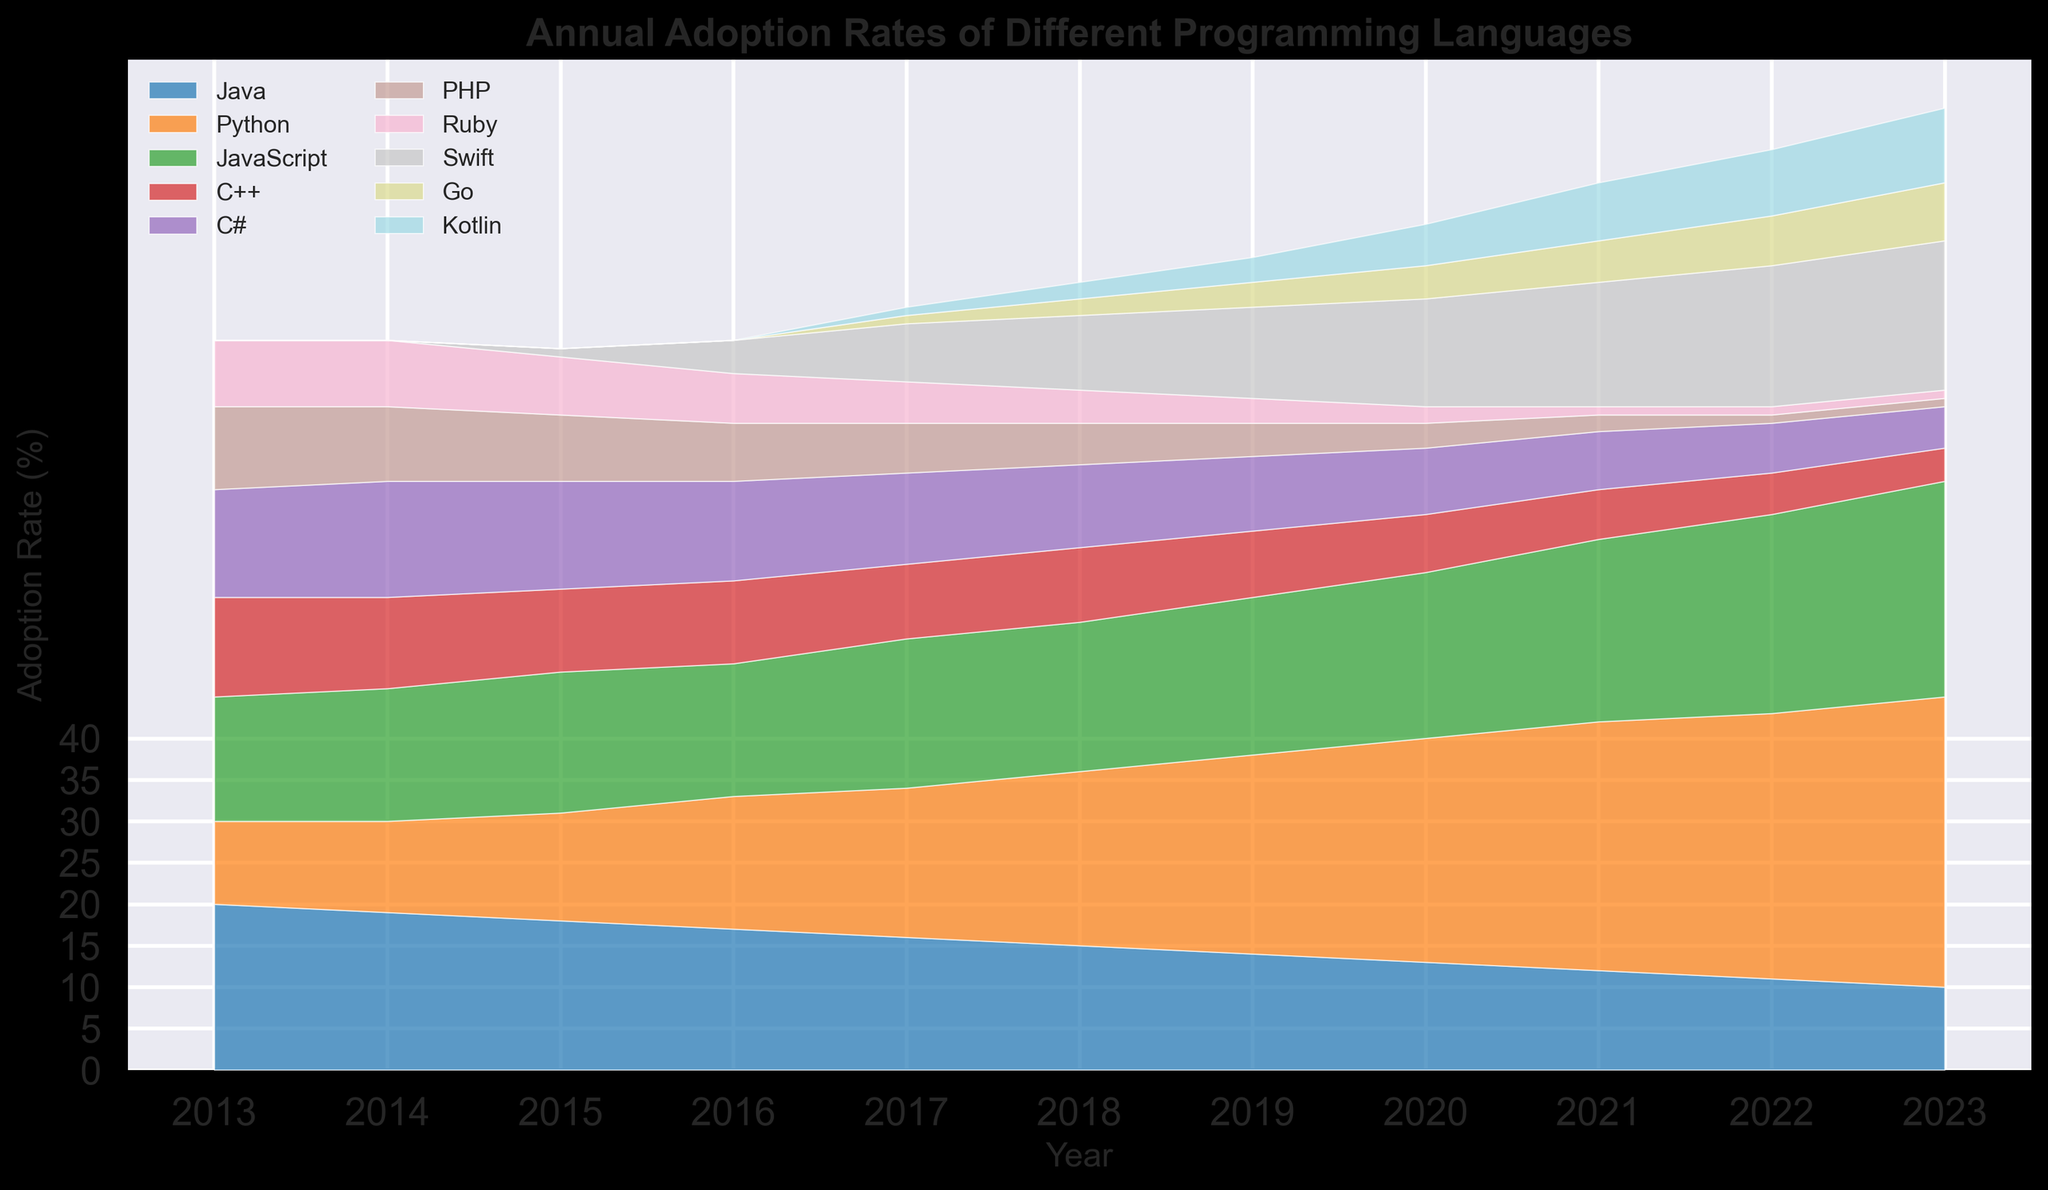Which programming language had the highest adoption rate in 2023? Look at the chart and find the top-most area in 2023. That area corresponds to Python, which has the most significant height.
Answer: Python In which year did Swift first appear, and what was its initial adoption rate? Find the year where Swift first shows an area. This occurred in 2015, with an adoption rate of 1%.
Answer: 2015, 1% How has the adoption rate of Java changed from 2013 to 2023? Identify the height of Java in 2013 and 2023. In 2013, it was 20%, and in 2023, it decreased to 10%. The adoption rate reduced by 10%.
Answer: Decreased by 10% Which two programming languages had an increasing adoption rate throughout the entire decade? Analyze the trends from 2013 to 2023 for all programming languages. Only Python and Swift show a consistently increasing trend over the entire period.
Answer: Python, Swift What are the programming languages with at least a 20% adoption rate in 2023, and what are their rates? Look at the areas in 2023 and find those with a height of 20% or more. Python (35%) and JavaScript (26%) meet this criterion.
Answer: Python (35%), JavaScript (26%) Between Python and JavaScript, which one had a more substantial increase in adoption rates from 2013 to 2023? Find the difference in adoption rates for both languages from 2013 to 2023. Python increased from 10% to 35% (increase of 25%), while JavaScript increased from 15% to 26% (increase of 11%).
Answer: Python What is the combined adoption rate of C++ and PHP in 2020? Identify the adoption rates of C++ and PHP in 2020 and sum them up. C++ is 7%, and PHP is 3%. Combined, it is 10%.
Answer: 10% Which programming language shows the steepest decline in adoption rate over the decade? Identify the language with the most significant decrease from 2013 to 2023. Java declined from 20% to 10%, which is the largest drop.
Answer: Java How did the adoption rate of Go change from 2015 to 2023? Observe the change in Go's height from 2015 to 2023. Go's rate increased from 0% in 2015 to 7% in 2023.
Answer: Increased by 7% What is the difference in the adoption rates of Swift and Kotlin in 2023? Look at the rates for both languages in 2023. Swift has 18% and Kotlin has 9%. The difference is 9%.
Answer: 9% 